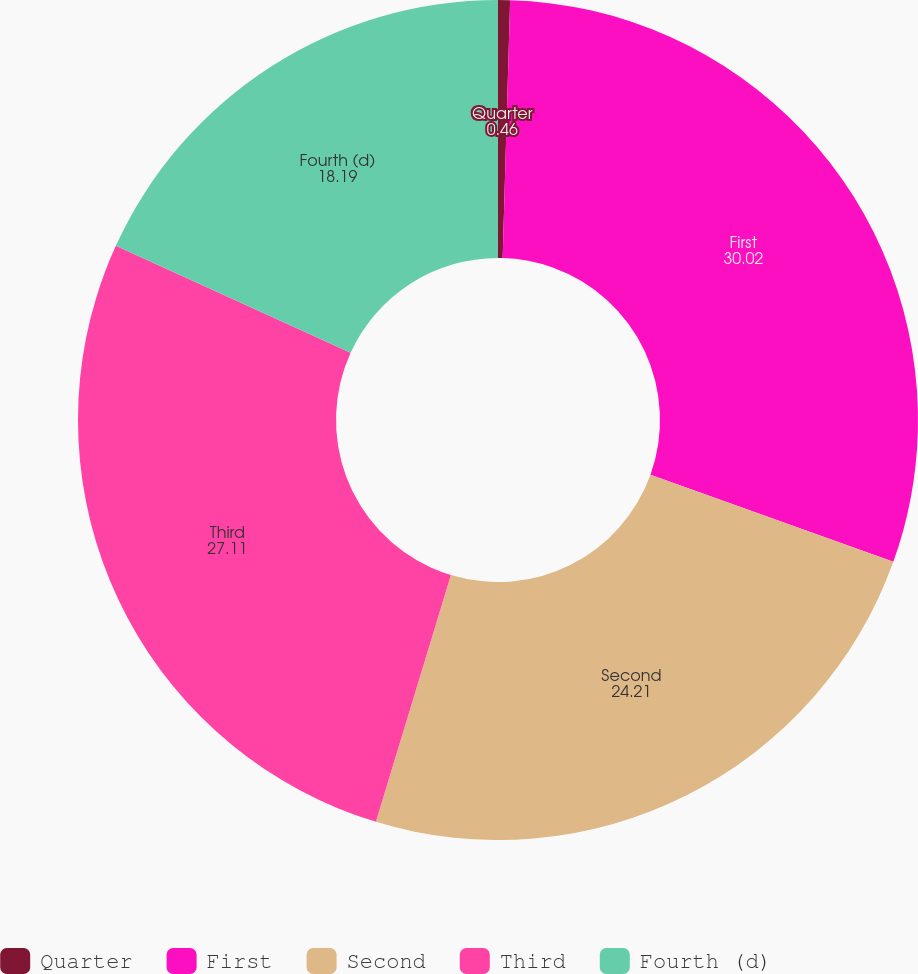Convert chart. <chart><loc_0><loc_0><loc_500><loc_500><pie_chart><fcel>Quarter<fcel>First<fcel>Second<fcel>Third<fcel>Fourth (d)<nl><fcel>0.46%<fcel>30.02%<fcel>24.21%<fcel>27.11%<fcel>18.19%<nl></chart> 